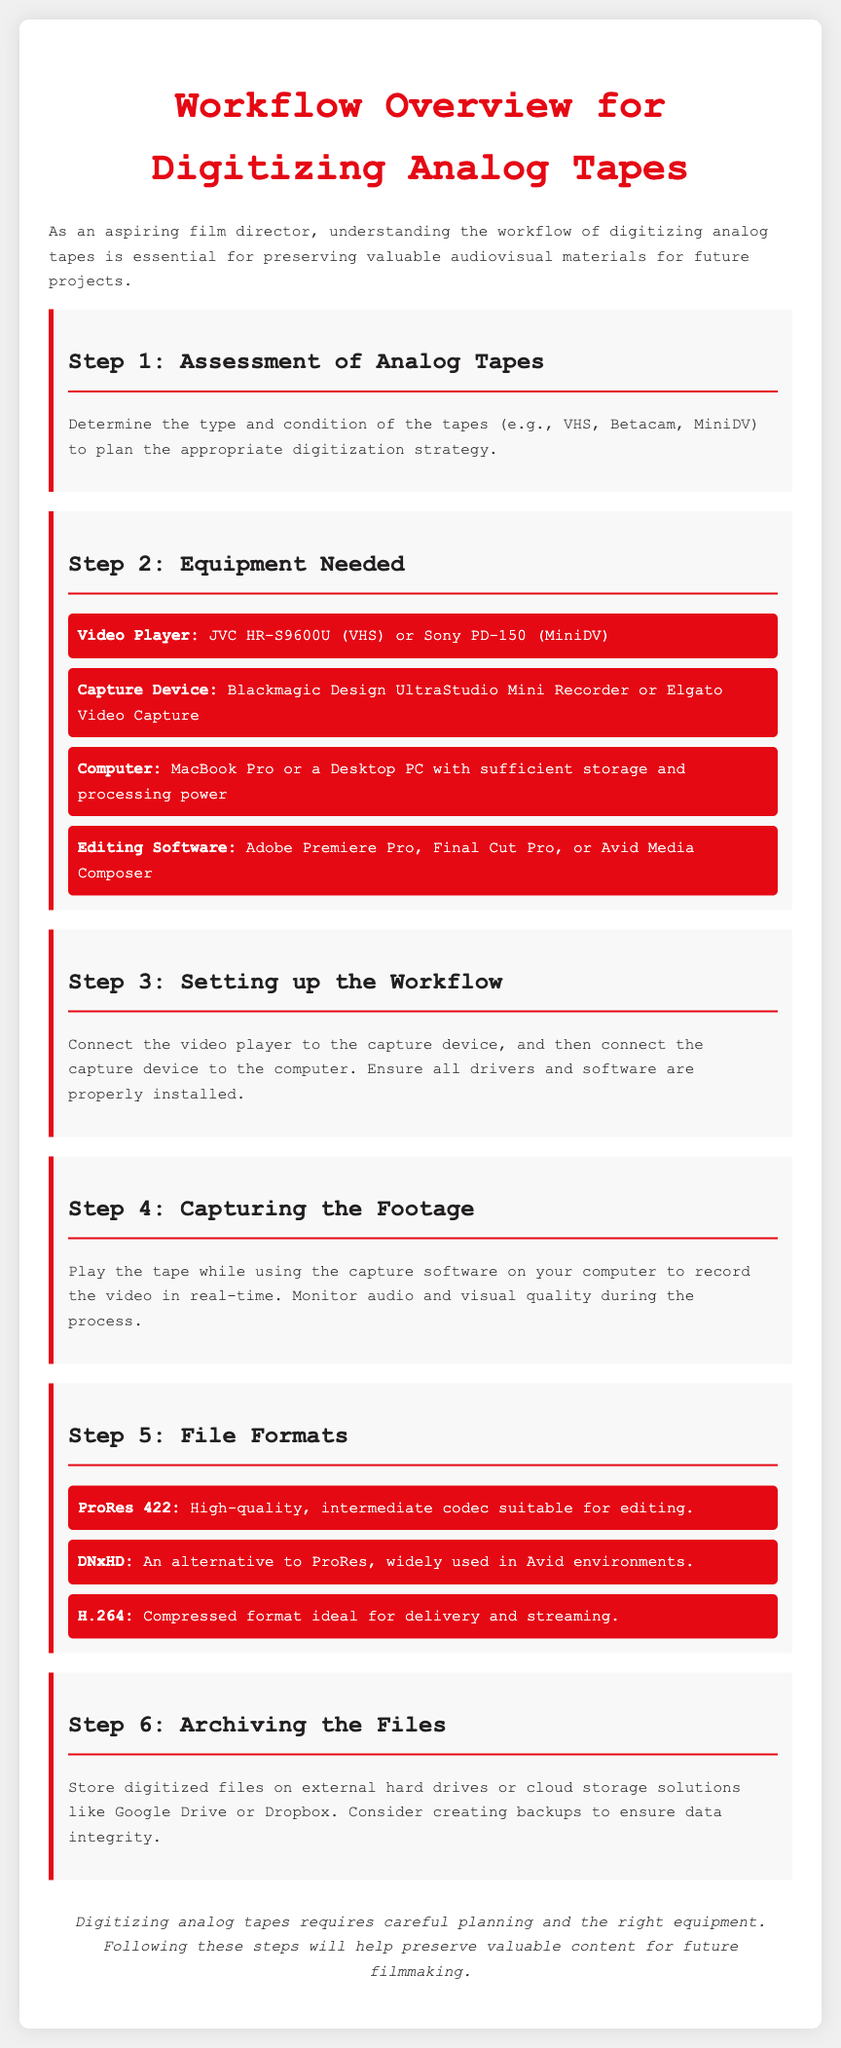What is the title of the document? The title of the document is provided in the header section as "Workflow Overview for Digitizing Analog Tapes."
Answer: Workflow Overview for Digitizing Analog Tapes What is the first step in the digitization workflow? The first step outlined in the document is to assess the analog tapes for type and condition.
Answer: Assessment of Analog Tapes Name one type of video player mentioned in the equipment list. The equipment section lists types of video players, one of which is JVC HR-S9600U.
Answer: JVC HR-S9600U What file format is suitable for editing? Among the file formats mentioned, ProRes 422 is noted as a high-quality intermediate codec suitable for editing.
Answer: ProRes 422 In which step is the video player connected to the capture device? The connection between the video player and the capture device occurs in Step 3, titled "Setting up the Workflow."
Answer: Step 3 What is the recommended storage solution for archiving files? The document suggests using external hard drives or cloud storage solutions for archiving.
Answer: External hard drives or cloud storage Which software is listed for editing? Editing software examples include Adobe Premiere Pro, one of the options listed.
Answer: Adobe Premiere Pro What does the workflow advise about monitoring during footage capture? The document advises to monitor audio and visual quality during the capturing process.
Answer: Monitor audio and visual quality Which is an alternative to ProRes mentioned in the file formats section? The file formats section mentions DNxHD as an alternative to ProRes.
Answer: DNxHD 